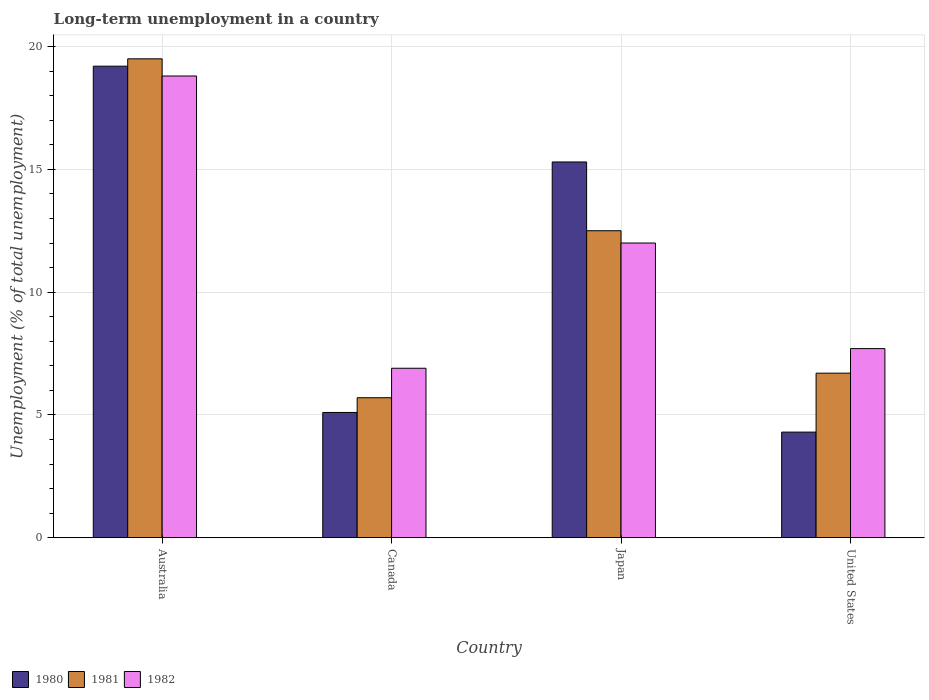How many different coloured bars are there?
Provide a short and direct response. 3. Are the number of bars per tick equal to the number of legend labels?
Ensure brevity in your answer.  Yes. How many bars are there on the 4th tick from the left?
Your response must be concise. 3. How many bars are there on the 2nd tick from the right?
Offer a very short reply. 3. What is the label of the 2nd group of bars from the left?
Make the answer very short. Canada. What is the percentage of long-term unemployed population in 1982 in Canada?
Offer a very short reply. 6.9. Across all countries, what is the maximum percentage of long-term unemployed population in 1982?
Ensure brevity in your answer.  18.8. Across all countries, what is the minimum percentage of long-term unemployed population in 1982?
Keep it short and to the point. 6.9. In which country was the percentage of long-term unemployed population in 1982 maximum?
Offer a very short reply. Australia. In which country was the percentage of long-term unemployed population in 1982 minimum?
Make the answer very short. Canada. What is the total percentage of long-term unemployed population in 1982 in the graph?
Give a very brief answer. 45.4. What is the difference between the percentage of long-term unemployed population in 1980 in Canada and that in United States?
Your answer should be compact. 0.8. What is the difference between the percentage of long-term unemployed population in 1981 in Canada and the percentage of long-term unemployed population in 1980 in Japan?
Ensure brevity in your answer.  -9.6. What is the average percentage of long-term unemployed population in 1981 per country?
Your response must be concise. 11.1. What is the difference between the percentage of long-term unemployed population of/in 1981 and percentage of long-term unemployed population of/in 1980 in United States?
Offer a very short reply. 2.4. In how many countries, is the percentage of long-term unemployed population in 1981 greater than 16 %?
Give a very brief answer. 1. What is the ratio of the percentage of long-term unemployed population in 1982 in Australia to that in United States?
Make the answer very short. 2.44. What is the difference between the highest and the second highest percentage of long-term unemployed population in 1982?
Offer a terse response. 6.8. What is the difference between the highest and the lowest percentage of long-term unemployed population in 1982?
Make the answer very short. 11.9. Is the sum of the percentage of long-term unemployed population in 1981 in Australia and United States greater than the maximum percentage of long-term unemployed population in 1982 across all countries?
Your response must be concise. Yes. How many bars are there?
Ensure brevity in your answer.  12. Are all the bars in the graph horizontal?
Offer a terse response. No. Are the values on the major ticks of Y-axis written in scientific E-notation?
Give a very brief answer. No. Does the graph contain any zero values?
Provide a succinct answer. No. What is the title of the graph?
Ensure brevity in your answer.  Long-term unemployment in a country. Does "2014" appear as one of the legend labels in the graph?
Your answer should be very brief. No. What is the label or title of the X-axis?
Give a very brief answer. Country. What is the label or title of the Y-axis?
Make the answer very short. Unemployment (% of total unemployment). What is the Unemployment (% of total unemployment) in 1980 in Australia?
Your answer should be compact. 19.2. What is the Unemployment (% of total unemployment) in 1982 in Australia?
Your answer should be very brief. 18.8. What is the Unemployment (% of total unemployment) of 1980 in Canada?
Keep it short and to the point. 5.1. What is the Unemployment (% of total unemployment) in 1981 in Canada?
Provide a succinct answer. 5.7. What is the Unemployment (% of total unemployment) of 1982 in Canada?
Your answer should be compact. 6.9. What is the Unemployment (% of total unemployment) in 1980 in Japan?
Make the answer very short. 15.3. What is the Unemployment (% of total unemployment) in 1981 in Japan?
Provide a short and direct response. 12.5. What is the Unemployment (% of total unemployment) in 1982 in Japan?
Give a very brief answer. 12. What is the Unemployment (% of total unemployment) in 1980 in United States?
Provide a short and direct response. 4.3. What is the Unemployment (% of total unemployment) of 1981 in United States?
Ensure brevity in your answer.  6.7. What is the Unemployment (% of total unemployment) in 1982 in United States?
Offer a very short reply. 7.7. Across all countries, what is the maximum Unemployment (% of total unemployment) in 1980?
Offer a very short reply. 19.2. Across all countries, what is the maximum Unemployment (% of total unemployment) in 1981?
Keep it short and to the point. 19.5. Across all countries, what is the maximum Unemployment (% of total unemployment) of 1982?
Make the answer very short. 18.8. Across all countries, what is the minimum Unemployment (% of total unemployment) of 1980?
Ensure brevity in your answer.  4.3. Across all countries, what is the minimum Unemployment (% of total unemployment) in 1981?
Give a very brief answer. 5.7. Across all countries, what is the minimum Unemployment (% of total unemployment) in 1982?
Make the answer very short. 6.9. What is the total Unemployment (% of total unemployment) in 1980 in the graph?
Your response must be concise. 43.9. What is the total Unemployment (% of total unemployment) of 1981 in the graph?
Keep it short and to the point. 44.4. What is the total Unemployment (% of total unemployment) in 1982 in the graph?
Offer a very short reply. 45.4. What is the difference between the Unemployment (% of total unemployment) in 1981 in Australia and that in Canada?
Give a very brief answer. 13.8. What is the difference between the Unemployment (% of total unemployment) in 1980 in Australia and that in Japan?
Make the answer very short. 3.9. What is the difference between the Unemployment (% of total unemployment) of 1982 in Australia and that in Japan?
Your answer should be very brief. 6.8. What is the difference between the Unemployment (% of total unemployment) of 1981 in Australia and that in United States?
Give a very brief answer. 12.8. What is the difference between the Unemployment (% of total unemployment) of 1982 in Australia and that in United States?
Make the answer very short. 11.1. What is the difference between the Unemployment (% of total unemployment) of 1980 in Canada and that in Japan?
Ensure brevity in your answer.  -10.2. What is the difference between the Unemployment (% of total unemployment) in 1982 in Canada and that in Japan?
Your answer should be very brief. -5.1. What is the difference between the Unemployment (% of total unemployment) in 1980 in Canada and that in United States?
Provide a succinct answer. 0.8. What is the difference between the Unemployment (% of total unemployment) of 1980 in Japan and that in United States?
Keep it short and to the point. 11. What is the difference between the Unemployment (% of total unemployment) in 1981 in Japan and that in United States?
Offer a terse response. 5.8. What is the difference between the Unemployment (% of total unemployment) in 1980 in Australia and the Unemployment (% of total unemployment) in 1981 in Canada?
Your answer should be compact. 13.5. What is the difference between the Unemployment (% of total unemployment) in 1980 in Australia and the Unemployment (% of total unemployment) in 1982 in Canada?
Ensure brevity in your answer.  12.3. What is the difference between the Unemployment (% of total unemployment) in 1981 in Australia and the Unemployment (% of total unemployment) in 1982 in Canada?
Give a very brief answer. 12.6. What is the difference between the Unemployment (% of total unemployment) in 1980 in Australia and the Unemployment (% of total unemployment) in 1981 in Japan?
Your response must be concise. 6.7. What is the difference between the Unemployment (% of total unemployment) in 1980 in Australia and the Unemployment (% of total unemployment) in 1982 in Japan?
Provide a short and direct response. 7.2. What is the difference between the Unemployment (% of total unemployment) of 1980 in Canada and the Unemployment (% of total unemployment) of 1981 in Japan?
Give a very brief answer. -7.4. What is the difference between the Unemployment (% of total unemployment) of 1980 in Canada and the Unemployment (% of total unemployment) of 1982 in United States?
Make the answer very short. -2.6. What is the difference between the Unemployment (% of total unemployment) in 1981 in Canada and the Unemployment (% of total unemployment) in 1982 in United States?
Offer a very short reply. -2. What is the difference between the Unemployment (% of total unemployment) in 1980 in Japan and the Unemployment (% of total unemployment) in 1981 in United States?
Offer a terse response. 8.6. What is the difference between the Unemployment (% of total unemployment) in 1980 in Japan and the Unemployment (% of total unemployment) in 1982 in United States?
Offer a very short reply. 7.6. What is the difference between the Unemployment (% of total unemployment) of 1981 in Japan and the Unemployment (% of total unemployment) of 1982 in United States?
Offer a very short reply. 4.8. What is the average Unemployment (% of total unemployment) of 1980 per country?
Provide a short and direct response. 10.97. What is the average Unemployment (% of total unemployment) of 1982 per country?
Ensure brevity in your answer.  11.35. What is the difference between the Unemployment (% of total unemployment) in 1980 and Unemployment (% of total unemployment) in 1981 in Canada?
Offer a very short reply. -0.6. What is the difference between the Unemployment (% of total unemployment) in 1980 and Unemployment (% of total unemployment) in 1982 in Canada?
Offer a very short reply. -1.8. What is the difference between the Unemployment (% of total unemployment) of 1981 and Unemployment (% of total unemployment) of 1982 in Japan?
Give a very brief answer. 0.5. What is the difference between the Unemployment (% of total unemployment) of 1980 and Unemployment (% of total unemployment) of 1982 in United States?
Your answer should be very brief. -3.4. What is the ratio of the Unemployment (% of total unemployment) of 1980 in Australia to that in Canada?
Make the answer very short. 3.76. What is the ratio of the Unemployment (% of total unemployment) in 1981 in Australia to that in Canada?
Provide a succinct answer. 3.42. What is the ratio of the Unemployment (% of total unemployment) of 1982 in Australia to that in Canada?
Ensure brevity in your answer.  2.72. What is the ratio of the Unemployment (% of total unemployment) of 1980 in Australia to that in Japan?
Your response must be concise. 1.25. What is the ratio of the Unemployment (% of total unemployment) in 1981 in Australia to that in Japan?
Keep it short and to the point. 1.56. What is the ratio of the Unemployment (% of total unemployment) in 1982 in Australia to that in Japan?
Offer a very short reply. 1.57. What is the ratio of the Unemployment (% of total unemployment) in 1980 in Australia to that in United States?
Provide a succinct answer. 4.47. What is the ratio of the Unemployment (% of total unemployment) in 1981 in Australia to that in United States?
Offer a terse response. 2.91. What is the ratio of the Unemployment (% of total unemployment) of 1982 in Australia to that in United States?
Give a very brief answer. 2.44. What is the ratio of the Unemployment (% of total unemployment) of 1981 in Canada to that in Japan?
Keep it short and to the point. 0.46. What is the ratio of the Unemployment (% of total unemployment) in 1982 in Canada to that in Japan?
Your answer should be compact. 0.57. What is the ratio of the Unemployment (% of total unemployment) in 1980 in Canada to that in United States?
Offer a very short reply. 1.19. What is the ratio of the Unemployment (% of total unemployment) in 1981 in Canada to that in United States?
Your response must be concise. 0.85. What is the ratio of the Unemployment (% of total unemployment) of 1982 in Canada to that in United States?
Give a very brief answer. 0.9. What is the ratio of the Unemployment (% of total unemployment) of 1980 in Japan to that in United States?
Provide a short and direct response. 3.56. What is the ratio of the Unemployment (% of total unemployment) in 1981 in Japan to that in United States?
Provide a short and direct response. 1.87. What is the ratio of the Unemployment (% of total unemployment) in 1982 in Japan to that in United States?
Provide a short and direct response. 1.56. What is the difference between the highest and the second highest Unemployment (% of total unemployment) of 1980?
Offer a very short reply. 3.9. What is the difference between the highest and the second highest Unemployment (% of total unemployment) in 1981?
Give a very brief answer. 7. What is the difference between the highest and the lowest Unemployment (% of total unemployment) of 1982?
Ensure brevity in your answer.  11.9. 